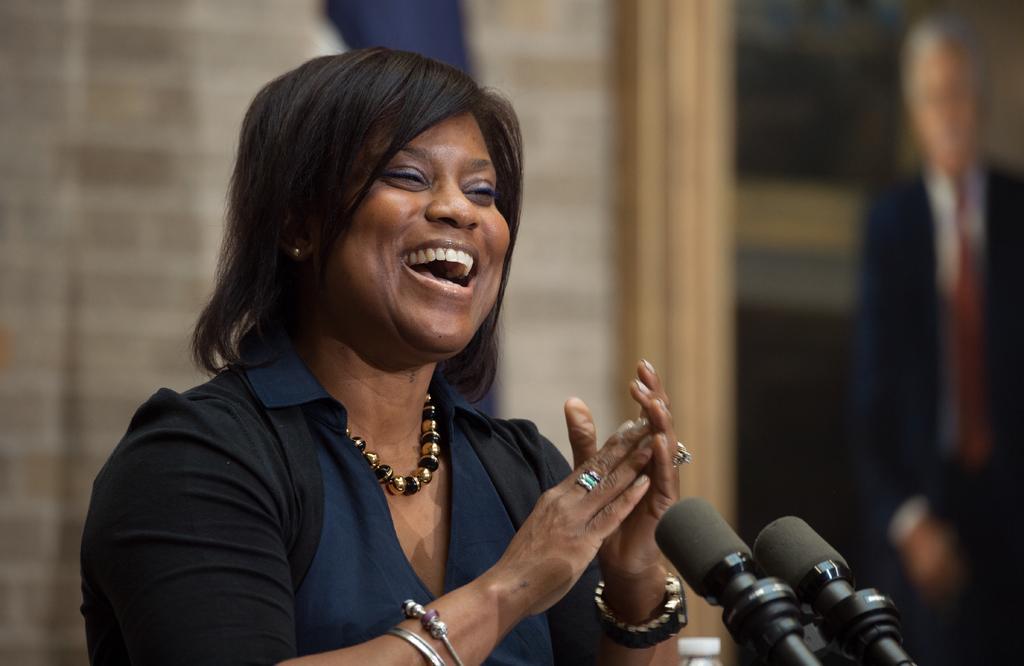In one or two sentences, can you explain what this image depicts? In this image there is a person, there are microphoneś, there is a photo frame. 